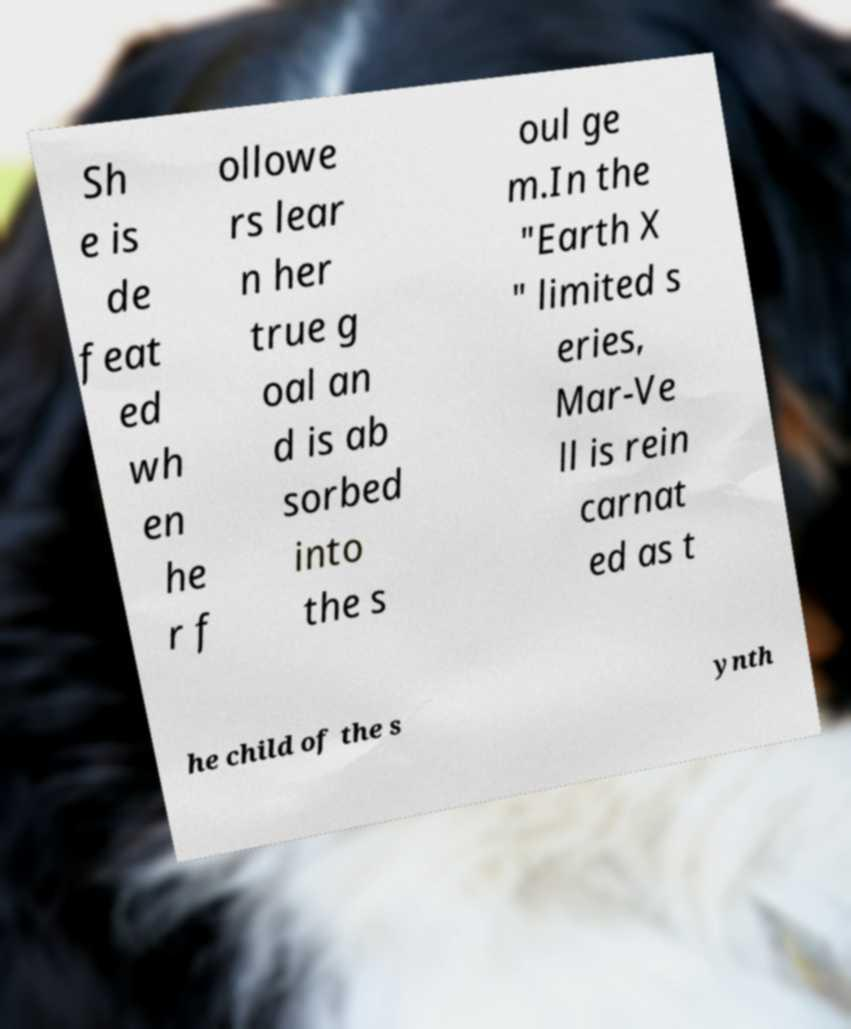Can you read and provide the text displayed in the image?This photo seems to have some interesting text. Can you extract and type it out for me? Sh e is de feat ed wh en he r f ollowe rs lear n her true g oal an d is ab sorbed into the s oul ge m.In the "Earth X " limited s eries, Mar-Ve ll is rein carnat ed as t he child of the s ynth 